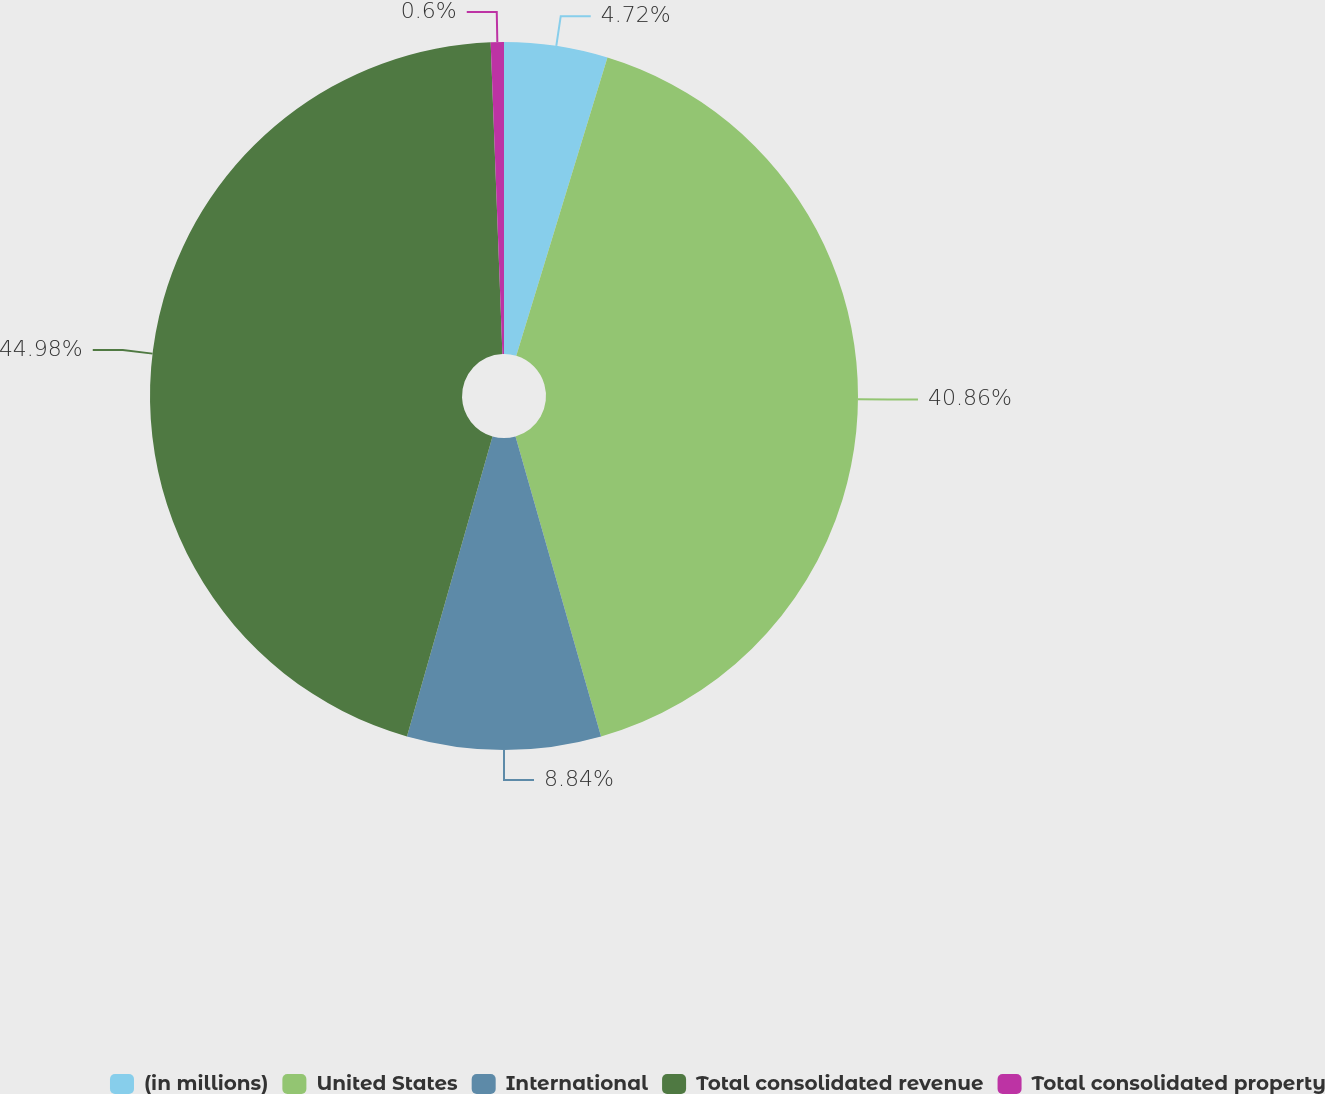Convert chart. <chart><loc_0><loc_0><loc_500><loc_500><pie_chart><fcel>(in millions)<fcel>United States<fcel>International<fcel>Total consolidated revenue<fcel>Total consolidated property<nl><fcel>4.72%<fcel>40.86%<fcel>8.84%<fcel>44.98%<fcel>0.6%<nl></chart> 